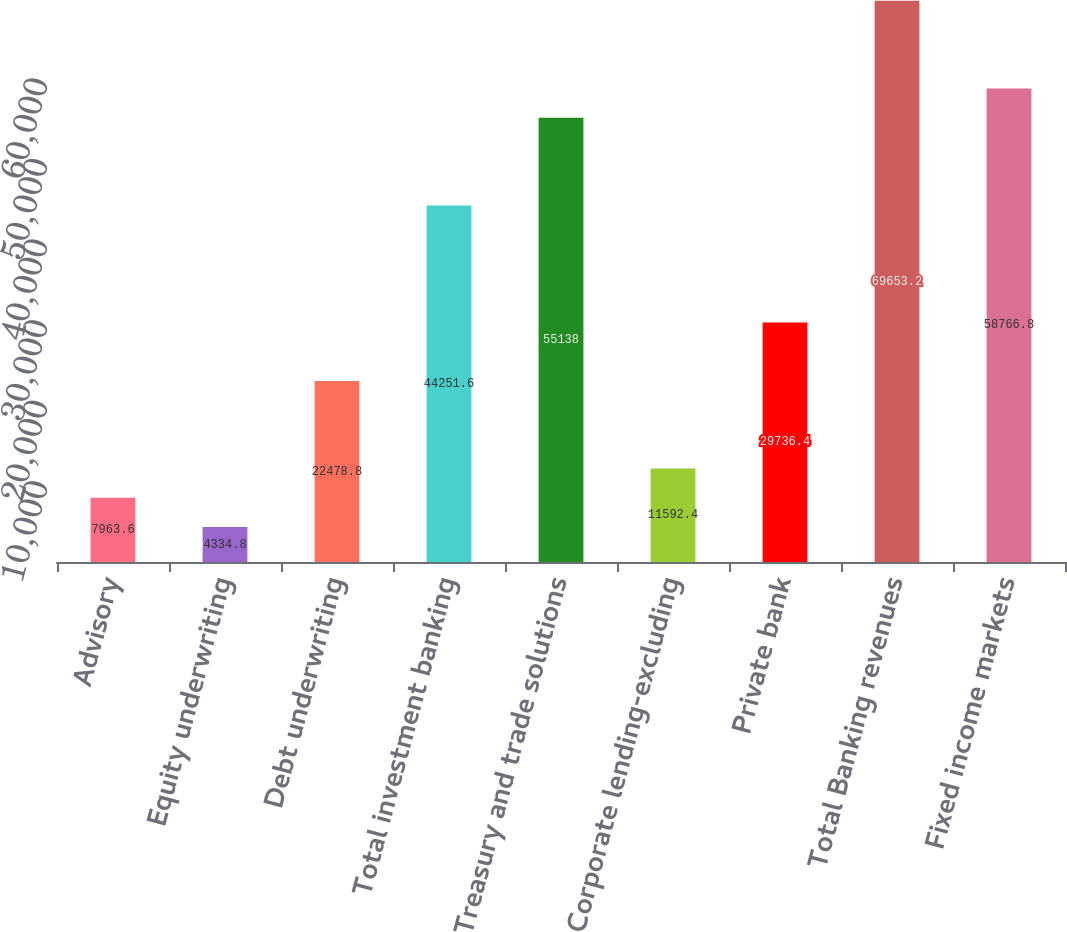Convert chart to OTSL. <chart><loc_0><loc_0><loc_500><loc_500><bar_chart><fcel>Advisory<fcel>Equity underwriting<fcel>Debt underwriting<fcel>Total investment banking<fcel>Treasury and trade solutions<fcel>Corporate lending-excluding<fcel>Private bank<fcel>Total Banking revenues<fcel>Fixed income markets<nl><fcel>7963.6<fcel>4334.8<fcel>22478.8<fcel>44251.6<fcel>55138<fcel>11592.4<fcel>29736.4<fcel>69653.2<fcel>58766.8<nl></chart> 